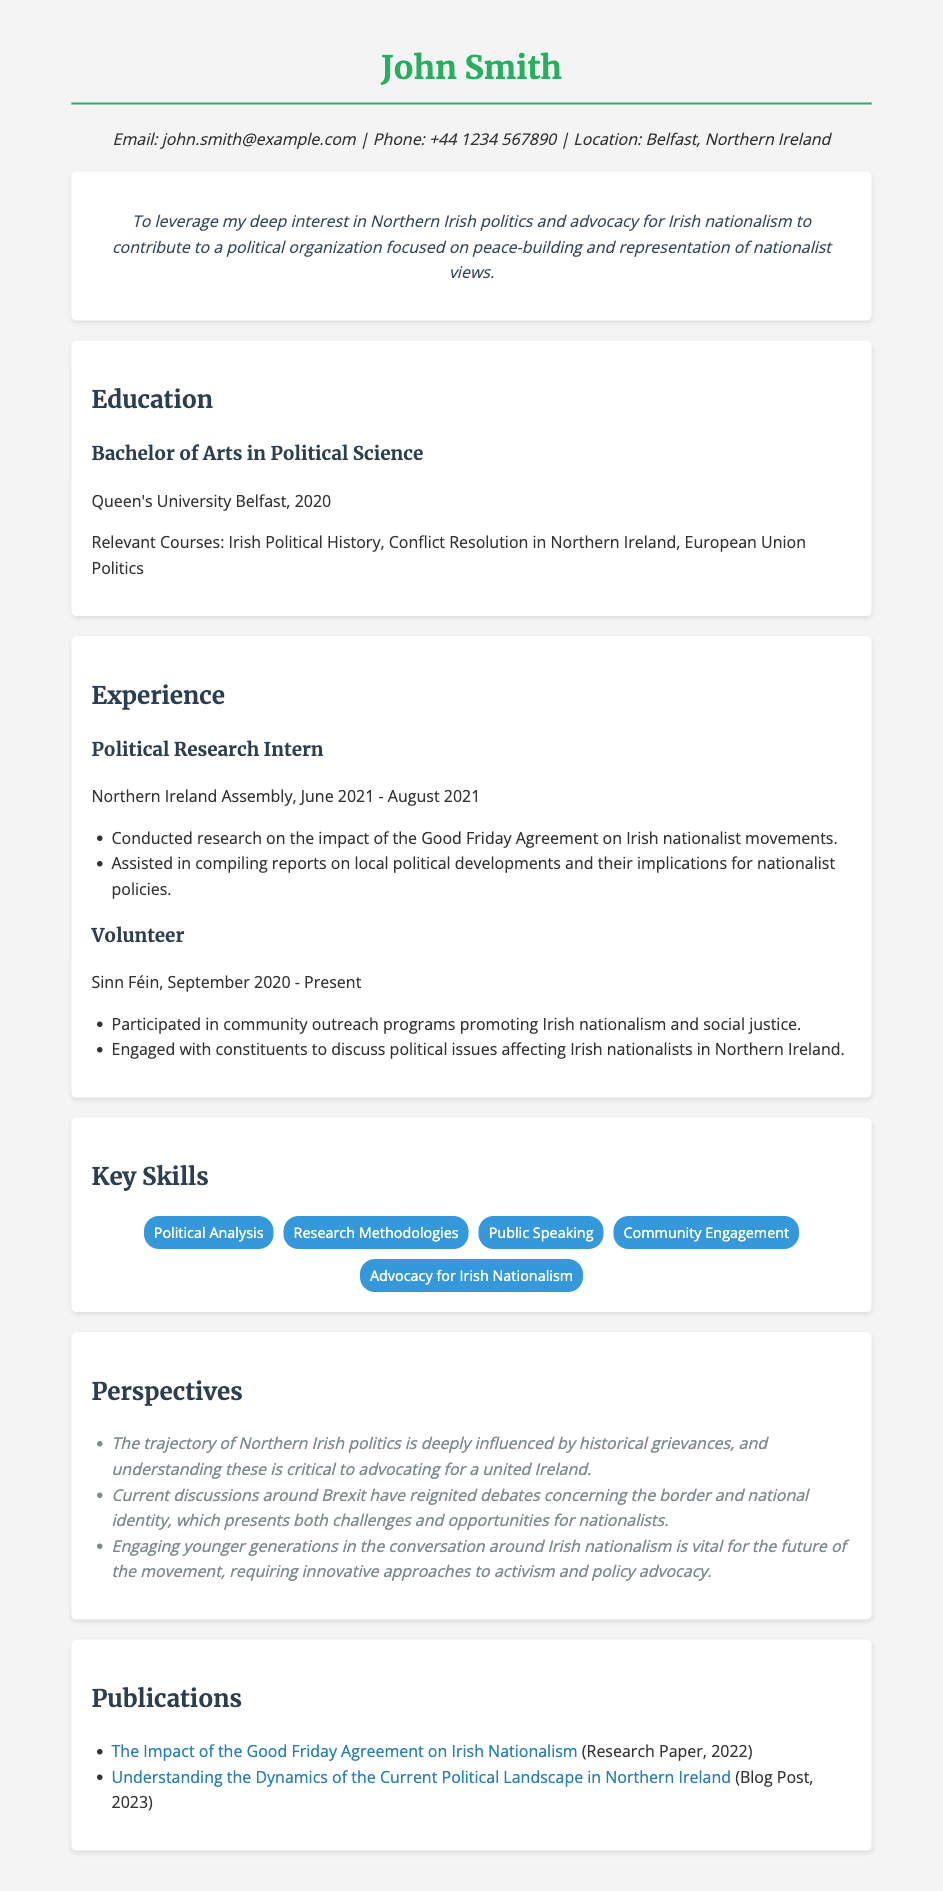What is the name of the individual in the resume? The resume showcases John Smith as the individual.
Answer: John Smith What is the highest level of education attained? The highest level of education listed is a Bachelor of Arts in Political Science.
Answer: Bachelor of Arts in Political Science Which university did John Smith attend? The resume states that John Smith attended Queen's University Belfast.
Answer: Queen's University Belfast What organization does John Smith volunteer for? The resume indicates that John Smith volunteers for Sinn Féin.
Answer: Sinn Féin What key skill is focused on advocacy for a specific ideology? The key skill mentioned related to ideology is Advocacy for Irish Nationalism.
Answer: Advocacy for Irish Nationalism What year did John Smith complete his degree? The resume specifies that John Smith completed his degree in 2020.
Answer: 2020 How long did John Smith work as a Political Research Intern? John Smith worked as a Political Research Intern for two months, from June to August 2021.
Answer: Two months What is the main objective stated in the resume? The objective focuses on leveraging interest in Northern Irish politics and advocacy for Irish nationalism.
Answer: Advocacy for Irish nationalism Which publication discusses the Good Friday Agreement? The resume lists "The Impact of the Good Friday Agreement on Irish Nationalism" as a publication.
Answer: The Impact of the Good Friday Agreement on Irish Nationalism 